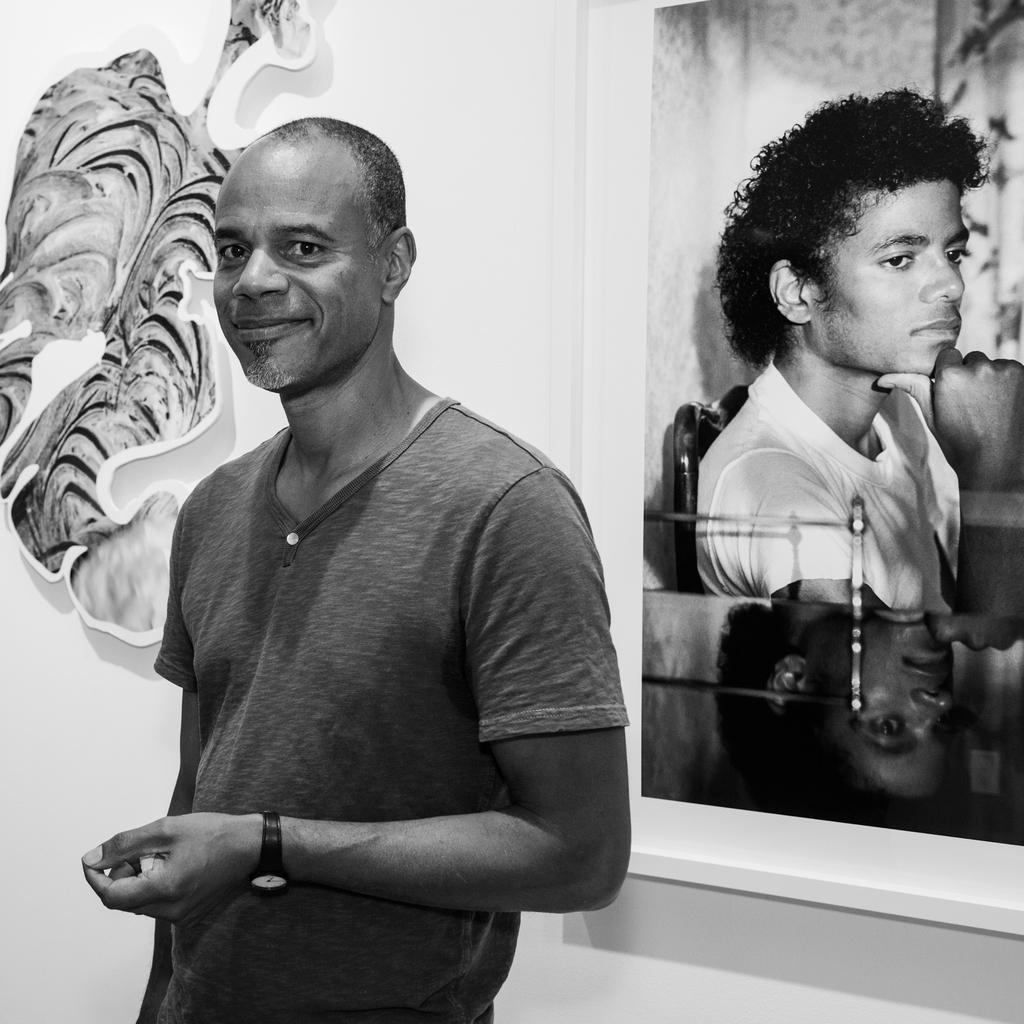What is the color scheme of the image? The image is black and white. Can you describe the person in the image? There is a person standing in the image. What additional detail can be found on the backside of the image? There is a sticker on the backside of the image. What can be seen on the wall in the image? There is a photo frame on a wall in the image. What type of office furniture is visible in the person's stomach in the image? There is no office furniture visible in the person's stomach in the image, as the image is black and white and only shows a person standing with a photo frame on a wall. 